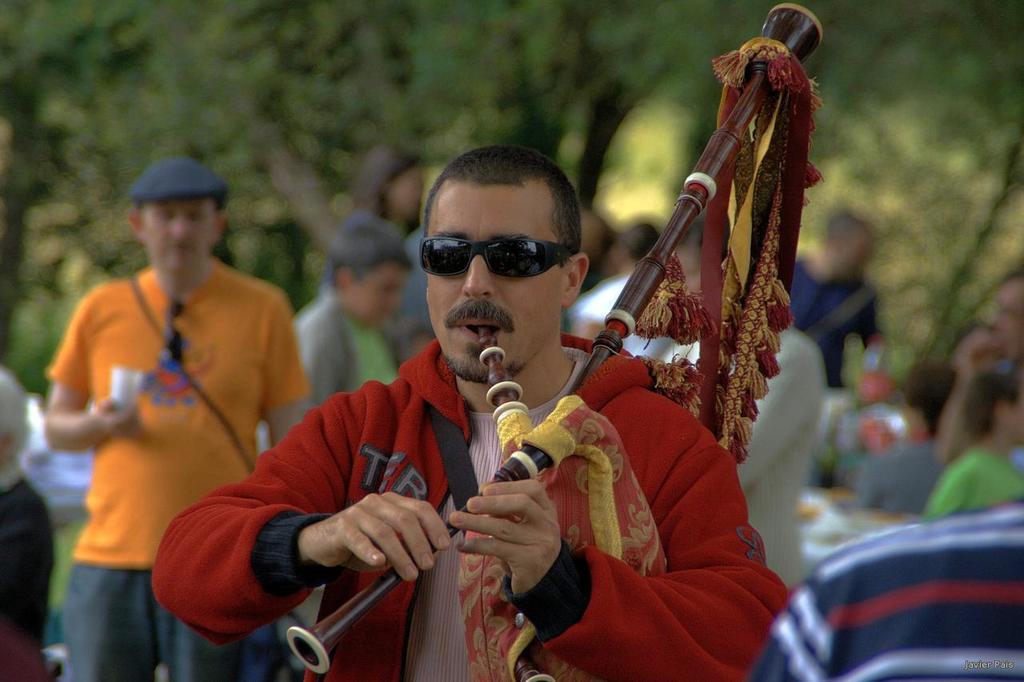Please provide a concise description of this image. In this image I can see there is a man playing a musical instrument and there are a few people standing behind him, there are few trees and the background of the image is blurred. 